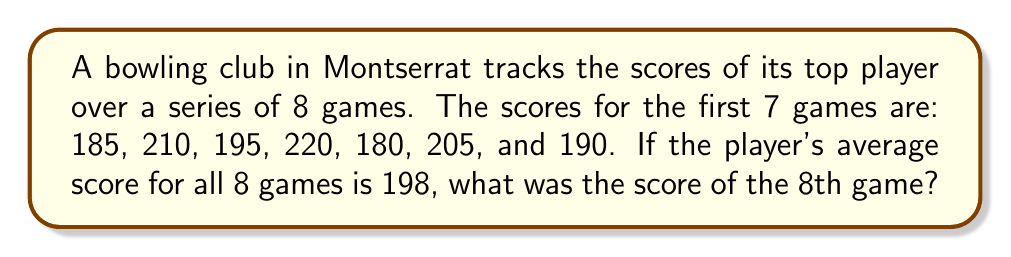Could you help me with this problem? Let's approach this step-by-step:

1) First, we need to understand what an average is. The average is calculated by dividing the sum of all scores by the number of games:

   $$ \text{Average} = \frac{\text{Sum of all scores}}{\text{Number of games}} $$

2) We know the average for all 8 games is 198. So we can set up the equation:

   $$ 198 = \frac{\text{Sum of all 8 scores}}{8} $$

3) Let's call the unknown 8th game score $x$. We can now write out the sum of all scores:

   $$ 198 = \frac{185 + 210 + 195 + 220 + 180 + 205 + 190 + x}{8} $$

4) Multiply both sides by 8:

   $$ 198 \cdot 8 = 185 + 210 + 195 + 220 + 180 + 205 + 190 + x $$

5) Simplify the left side:

   $$ 1584 = 185 + 210 + 195 + 220 + 180 + 205 + 190 + x $$

6) Add up the known scores on the right side:

   $$ 1584 = 1385 + x $$

7) Subtract 1385 from both sides:

   $$ 199 = x $$

Therefore, the score of the 8th game was 199.
Answer: 199 